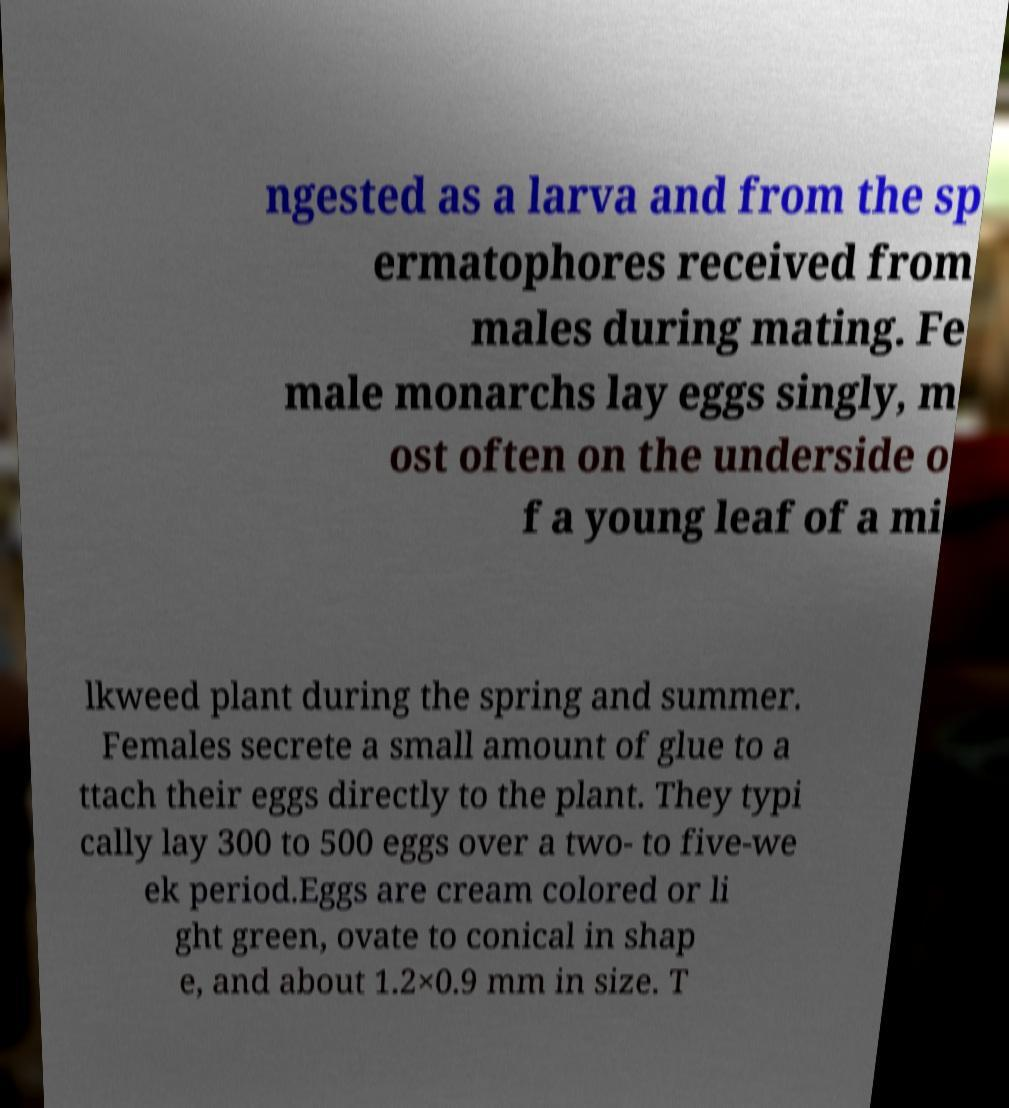Could you assist in decoding the text presented in this image and type it out clearly? ngested as a larva and from the sp ermatophores received from males during mating. Fe male monarchs lay eggs singly, m ost often on the underside o f a young leaf of a mi lkweed plant during the spring and summer. Females secrete a small amount of glue to a ttach their eggs directly to the plant. They typi cally lay 300 to 500 eggs over a two- to five-we ek period.Eggs are cream colored or li ght green, ovate to conical in shap e, and about 1.2×0.9 mm in size. T 